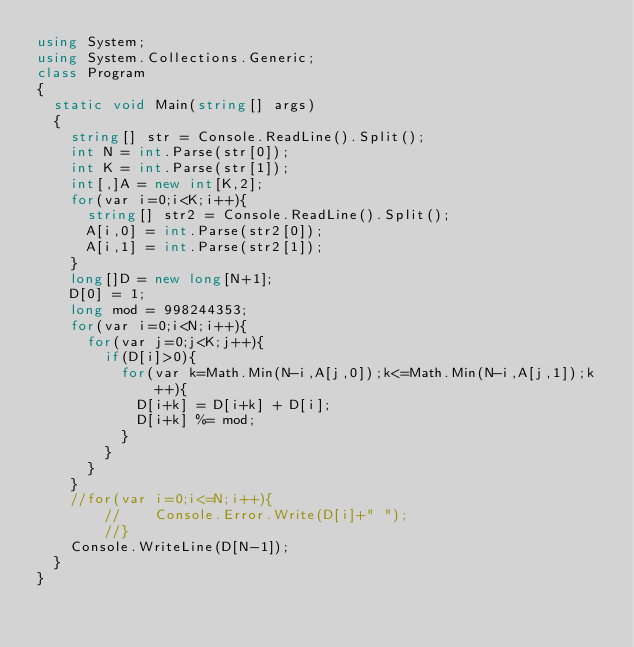<code> <loc_0><loc_0><loc_500><loc_500><_C#_>using System;
using System.Collections.Generic;
class Program
{
	static void Main(string[] args)
	{
		string[] str = Console.ReadLine().Split();
		int N = int.Parse(str[0]);
		int K = int.Parse(str[1]);
		int[,]A = new int[K,2];
		for(var i=0;i<K;i++){
			string[] str2 = Console.ReadLine().Split();
			A[i,0] = int.Parse(str2[0]);
			A[i,1] = int.Parse(str2[1]);
		}
		long[]D = new long[N+1];
		D[0] = 1;
		long mod = 998244353;
		for(var i=0;i<N;i++){
			for(var j=0;j<K;j++){
				if(D[i]>0){
					for(var k=Math.Min(N-i,A[j,0]);k<=Math.Min(N-i,A[j,1]);k++){
						D[i+k] = D[i+k] + D[i];
						D[i+k] %= mod;
					}
				}
			}
		}
		//for(var i=0;i<=N;i++){
        //  	Console.Error.Write(D[i]+" ");
        //}
		Console.WriteLine(D[N-1]);
	}
}</code> 